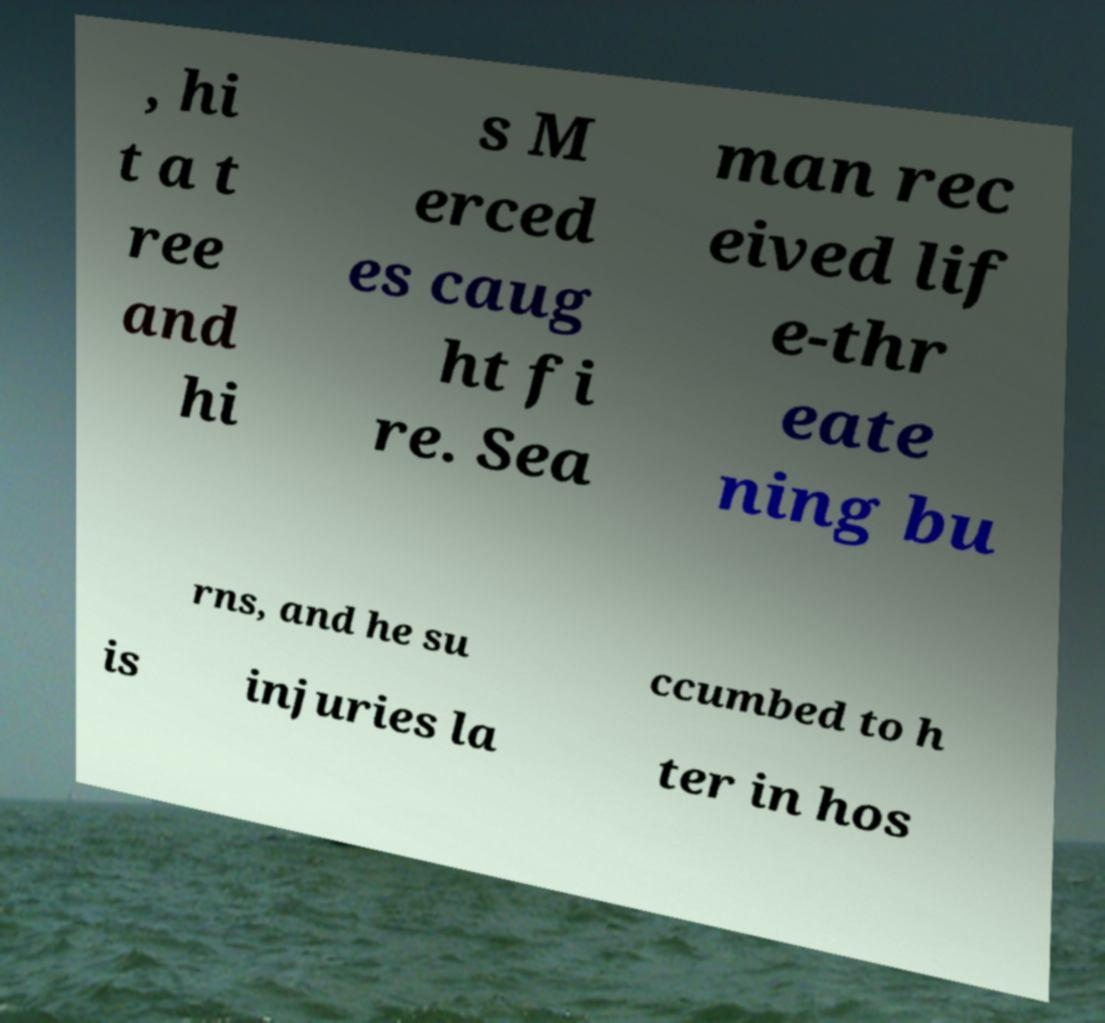Please read and relay the text visible in this image. What does it say? , hi t a t ree and hi s M erced es caug ht fi re. Sea man rec eived lif e-thr eate ning bu rns, and he su ccumbed to h is injuries la ter in hos 